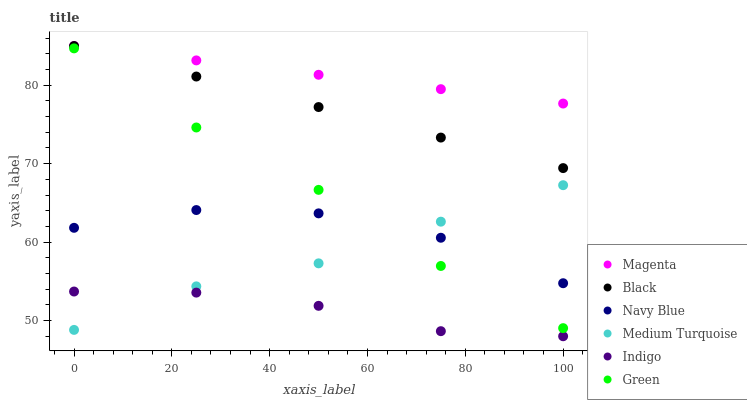Does Indigo have the minimum area under the curve?
Answer yes or no. Yes. Does Magenta have the maximum area under the curve?
Answer yes or no. Yes. Does Navy Blue have the minimum area under the curve?
Answer yes or no. No. Does Navy Blue have the maximum area under the curve?
Answer yes or no. No. Is Magenta the smoothest?
Answer yes or no. Yes. Is Navy Blue the roughest?
Answer yes or no. Yes. Is Green the smoothest?
Answer yes or no. No. Is Green the roughest?
Answer yes or no. No. Does Indigo have the lowest value?
Answer yes or no. Yes. Does Navy Blue have the lowest value?
Answer yes or no. No. Does Magenta have the highest value?
Answer yes or no. Yes. Does Navy Blue have the highest value?
Answer yes or no. No. Is Green less than Magenta?
Answer yes or no. Yes. Is Black greater than Green?
Answer yes or no. Yes. Does Medium Turquoise intersect Navy Blue?
Answer yes or no. Yes. Is Medium Turquoise less than Navy Blue?
Answer yes or no. No. Is Medium Turquoise greater than Navy Blue?
Answer yes or no. No. Does Green intersect Magenta?
Answer yes or no. No. 